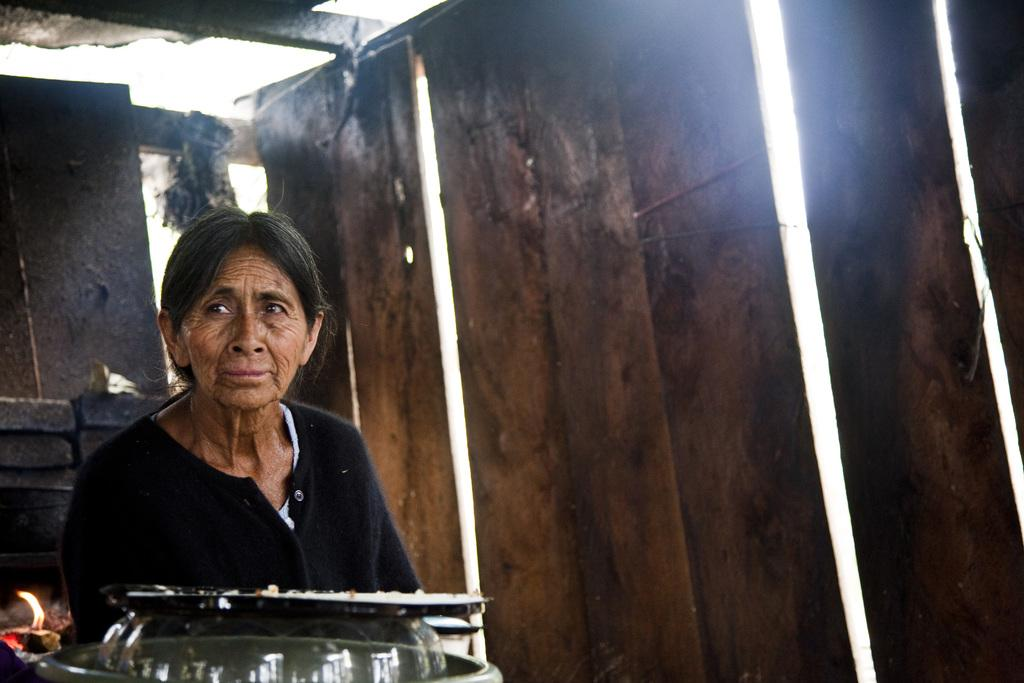Who is present in the image? There is a woman in the image. What is in front of the woman? There are objects in front of the woman. What can be seen in the image that is related to heat or fire? There is a flame visible in the image. What type of structure is present in the image? There is a wall in the image. What type of material is visible in the image? There are wooden planks in the image. What type of soap is being used to clean the plants in the image? There are no plants or soap present in the image. 